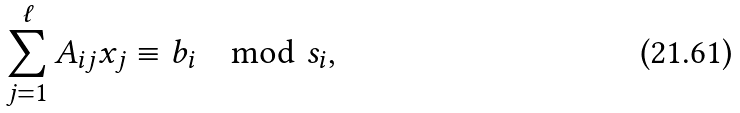Convert formula to latex. <formula><loc_0><loc_0><loc_500><loc_500>\sum _ { j = 1 } ^ { \ell } A _ { i j } x _ { j } \equiv b _ { i } \mod s _ { i } ,</formula> 